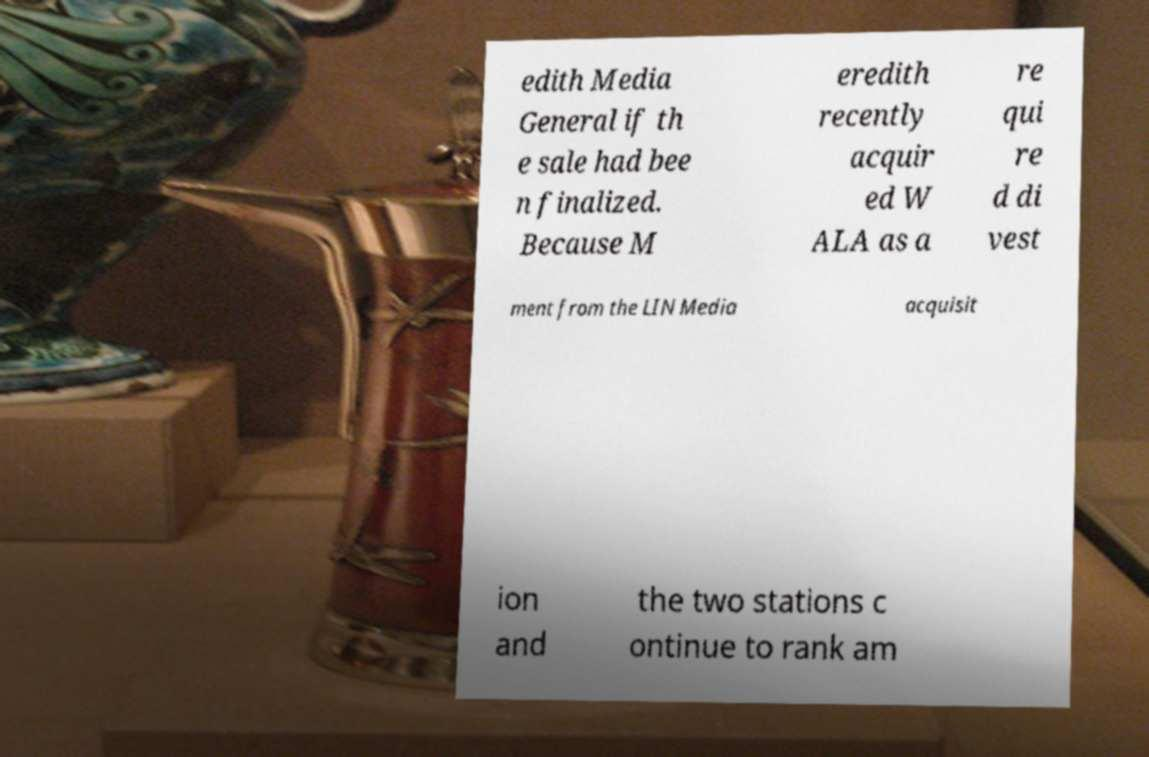Can you read and provide the text displayed in the image?This photo seems to have some interesting text. Can you extract and type it out for me? edith Media General if th e sale had bee n finalized. Because M eredith recently acquir ed W ALA as a re qui re d di vest ment from the LIN Media acquisit ion and the two stations c ontinue to rank am 